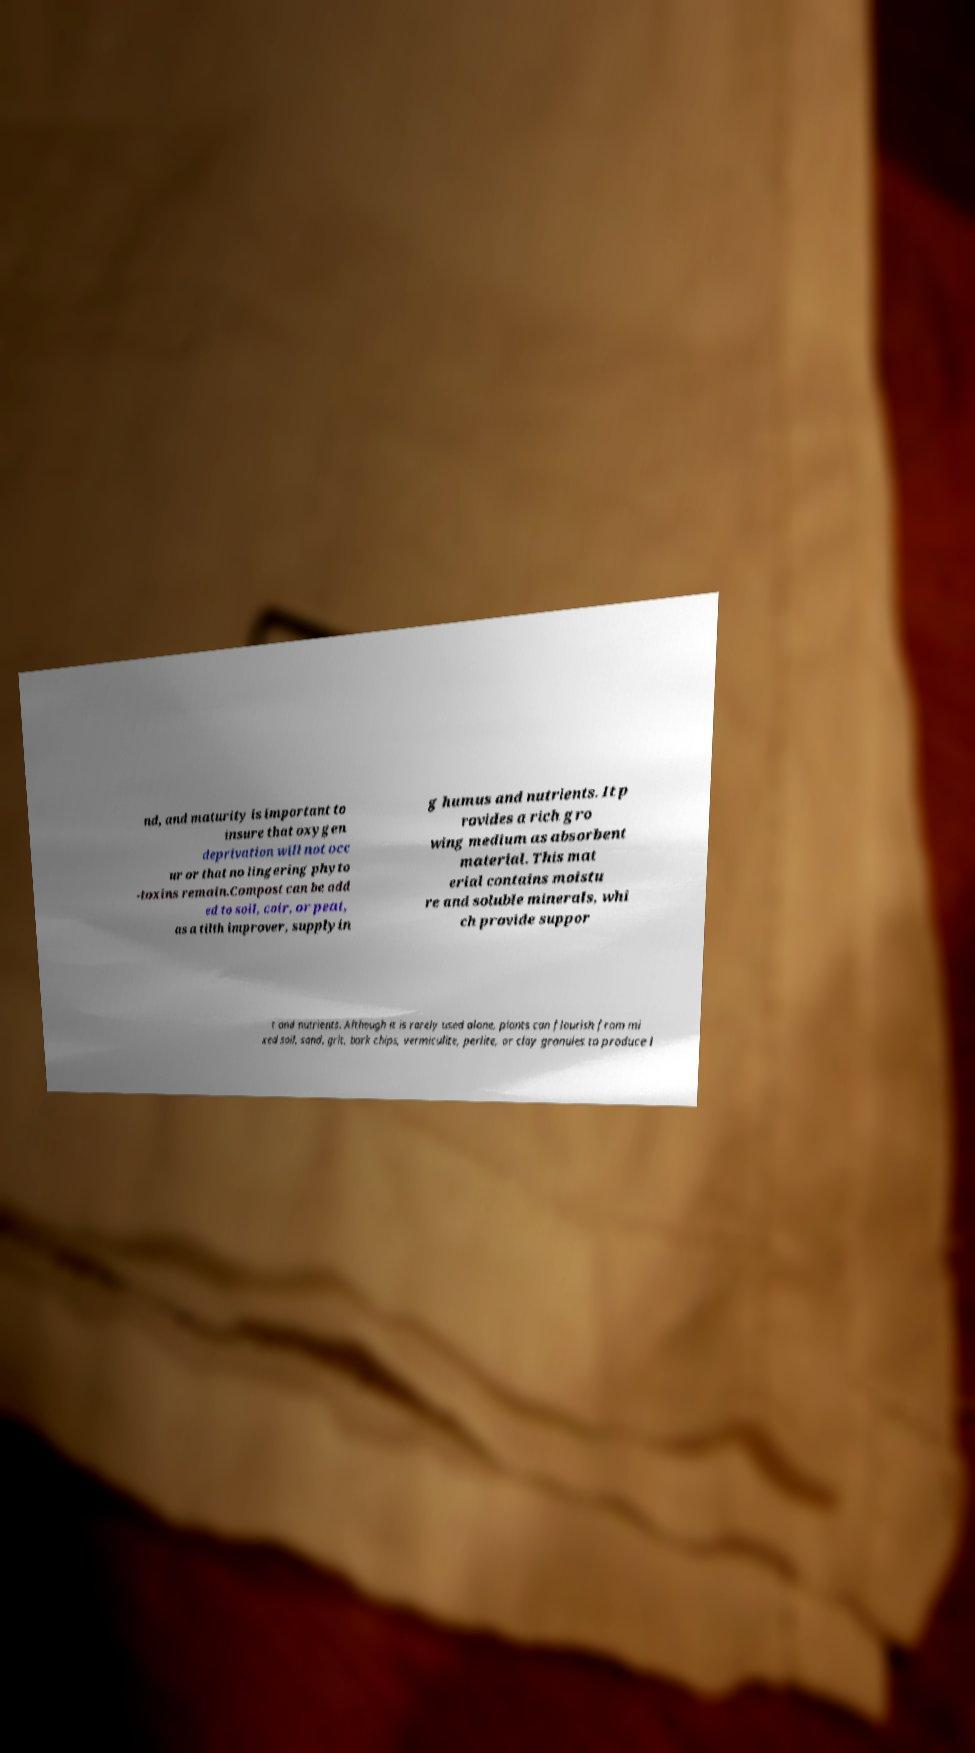Could you assist in decoding the text presented in this image and type it out clearly? nd, and maturity is important to insure that oxygen deprivation will not occ ur or that no lingering phyto -toxins remain.Compost can be add ed to soil, coir, or peat, as a tilth improver, supplyin g humus and nutrients. It p rovides a rich gro wing medium as absorbent material. This mat erial contains moistu re and soluble minerals, whi ch provide suppor t and nutrients. Although it is rarely used alone, plants can flourish from mi xed soil, sand, grit, bark chips, vermiculite, perlite, or clay granules to produce l 